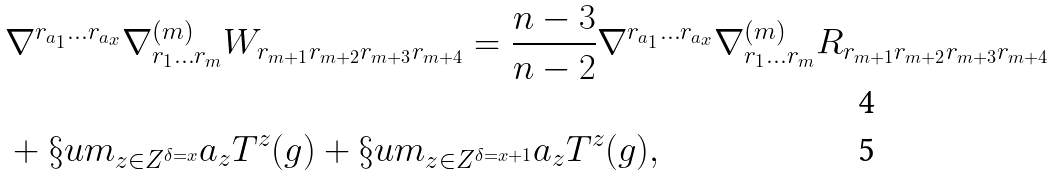<formula> <loc_0><loc_0><loc_500><loc_500>& \nabla ^ { r _ { a _ { 1 } } \dots r _ { a _ { x } } } \nabla ^ { ( m ) } _ { r _ { 1 } \dots r _ { m } } W _ { r _ { m + 1 } r _ { m + 2 } r _ { m + 3 } r _ { m + 4 } } = \frac { n - 3 } { n - 2 } \nabla ^ { r _ { a _ { 1 } } \dots r _ { a _ { x } } } \nabla ^ { ( m ) } _ { r _ { 1 } \dots r _ { m } } R _ { r _ { m + 1 } r _ { m + 2 } r _ { m + 3 } r _ { m + 4 } } \\ & + \S u m _ { z \in Z ^ { \delta = x } } a _ { z } T ^ { z } ( g ) + \S u m _ { z \in Z ^ { \delta = x + 1 } } a _ { z } T ^ { z } ( g ) ,</formula> 